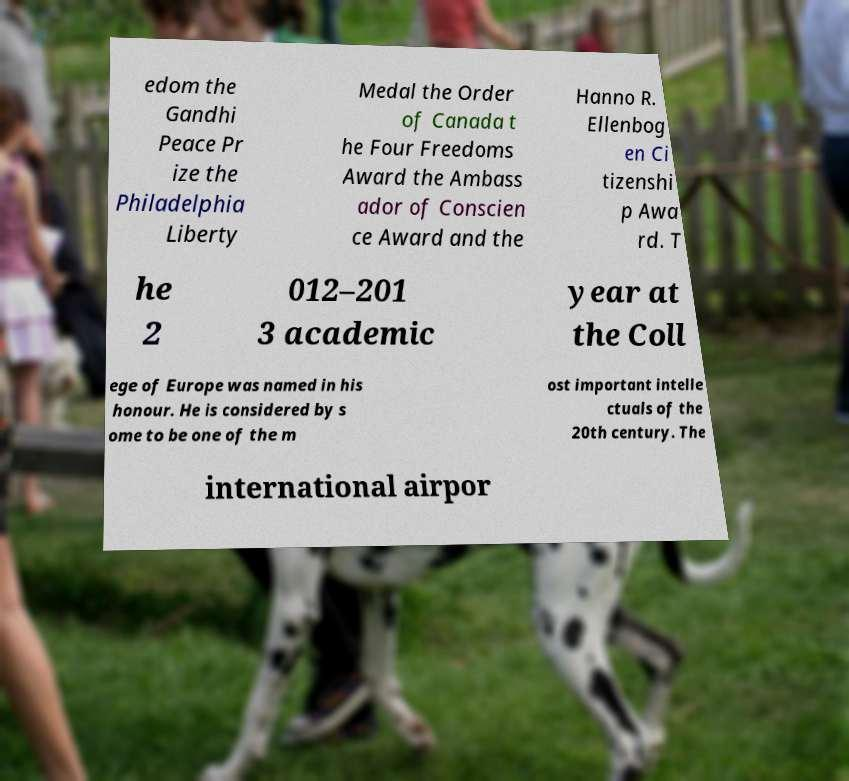Can you read and provide the text displayed in the image?This photo seems to have some interesting text. Can you extract and type it out for me? edom the Gandhi Peace Pr ize the Philadelphia Liberty Medal the Order of Canada t he Four Freedoms Award the Ambass ador of Conscien ce Award and the Hanno R. Ellenbog en Ci tizenshi p Awa rd. T he 2 012–201 3 academic year at the Coll ege of Europe was named in his honour. He is considered by s ome to be one of the m ost important intelle ctuals of the 20th century. The international airpor 